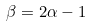<formula> <loc_0><loc_0><loc_500><loc_500>\beta = 2 \alpha - 1</formula> 